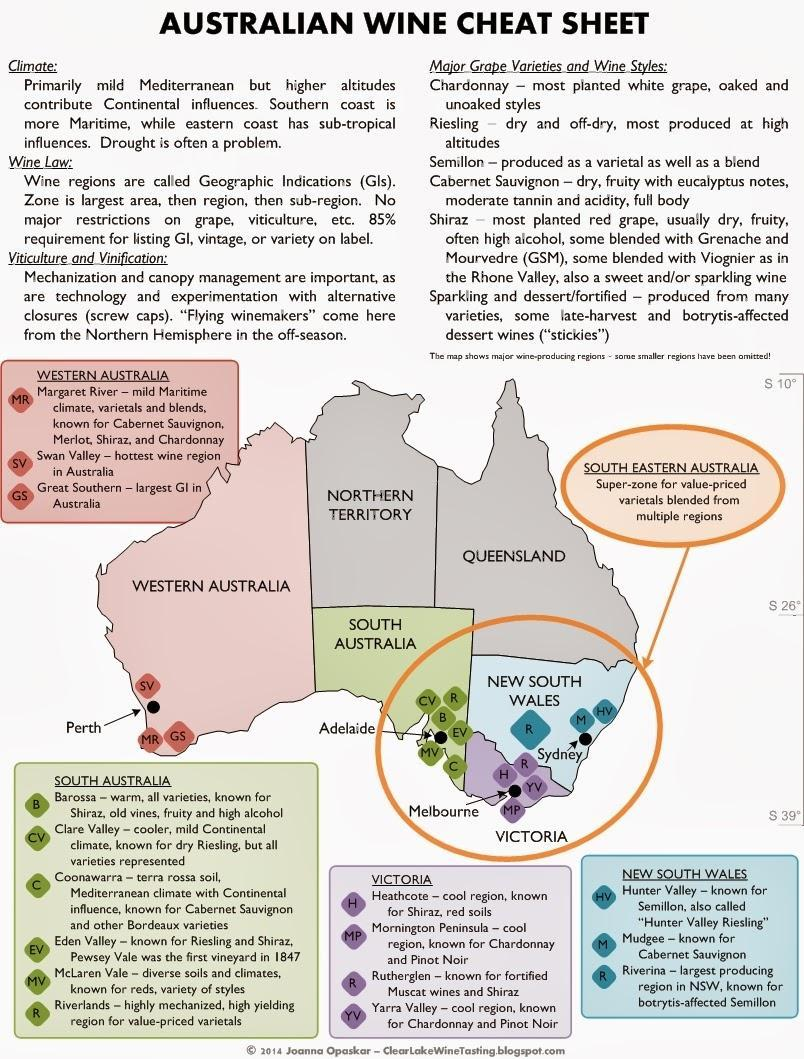What color is South Australia in the map, blue, green or grey?
Answer the question with a short phrase. green. Which region is known for botrytis-affected Semillon? Riverina. Which wine has high alcohol often? Shiraz. What color is New South Wales in the map, blue, green or grey? blue. Which is the largest Geographic Indication in Australia? Great Southern. Which region has red soil? Heathcote. 